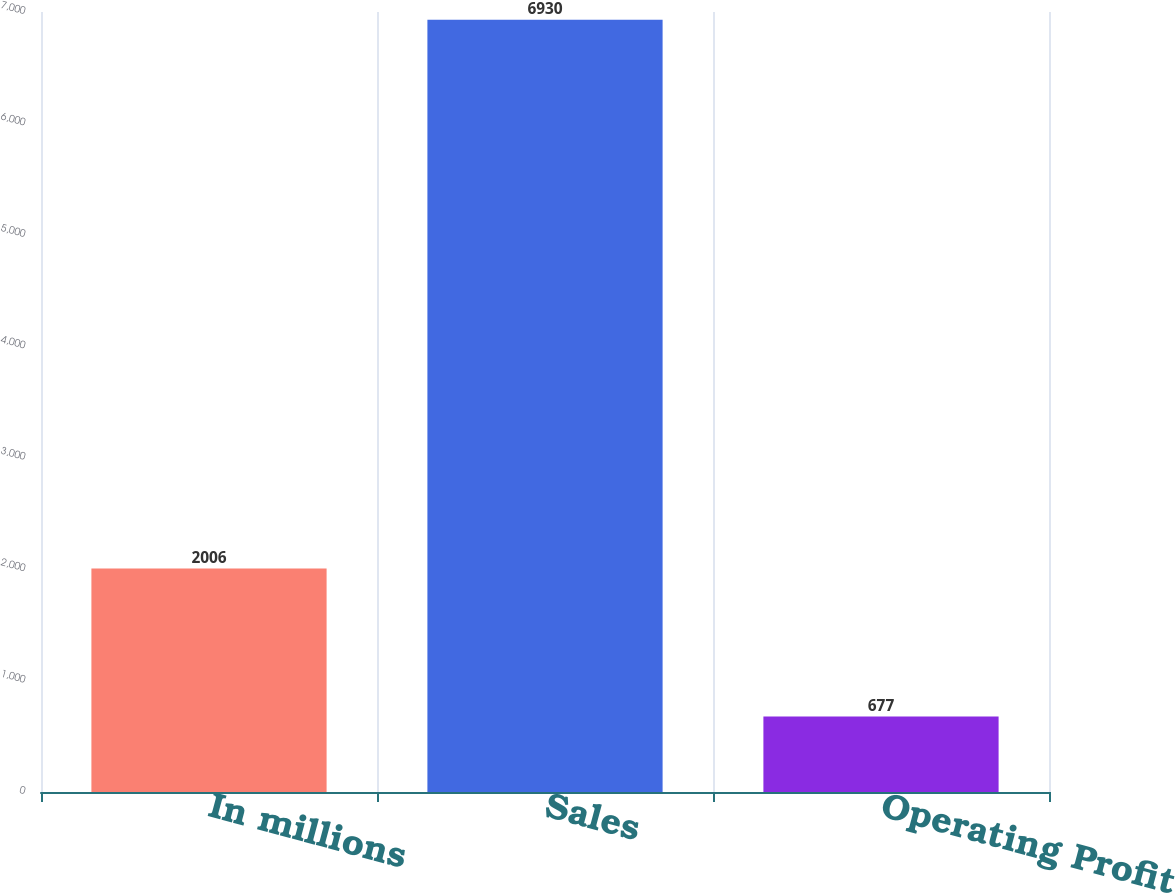Convert chart. <chart><loc_0><loc_0><loc_500><loc_500><bar_chart><fcel>In millions<fcel>Sales<fcel>Operating Profit<nl><fcel>2006<fcel>6930<fcel>677<nl></chart> 